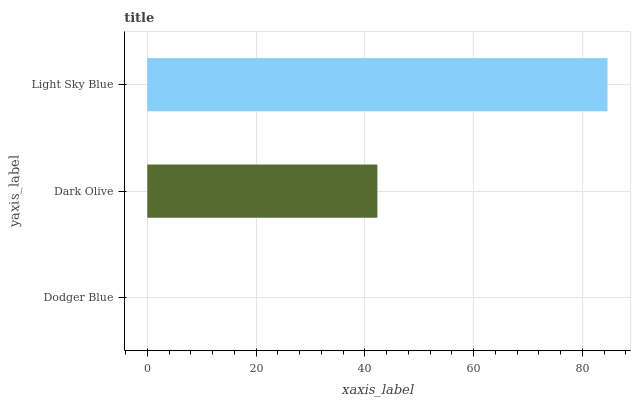Is Dodger Blue the minimum?
Answer yes or no. Yes. Is Light Sky Blue the maximum?
Answer yes or no. Yes. Is Dark Olive the minimum?
Answer yes or no. No. Is Dark Olive the maximum?
Answer yes or no. No. Is Dark Olive greater than Dodger Blue?
Answer yes or no. Yes. Is Dodger Blue less than Dark Olive?
Answer yes or no. Yes. Is Dodger Blue greater than Dark Olive?
Answer yes or no. No. Is Dark Olive less than Dodger Blue?
Answer yes or no. No. Is Dark Olive the high median?
Answer yes or no. Yes. Is Dark Olive the low median?
Answer yes or no. Yes. Is Dodger Blue the high median?
Answer yes or no. No. Is Light Sky Blue the low median?
Answer yes or no. No. 